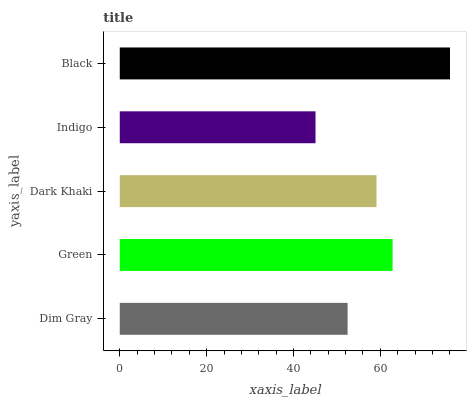Is Indigo the minimum?
Answer yes or no. Yes. Is Black the maximum?
Answer yes or no. Yes. Is Green the minimum?
Answer yes or no. No. Is Green the maximum?
Answer yes or no. No. Is Green greater than Dim Gray?
Answer yes or no. Yes. Is Dim Gray less than Green?
Answer yes or no. Yes. Is Dim Gray greater than Green?
Answer yes or no. No. Is Green less than Dim Gray?
Answer yes or no. No. Is Dark Khaki the high median?
Answer yes or no. Yes. Is Dark Khaki the low median?
Answer yes or no. Yes. Is Green the high median?
Answer yes or no. No. Is Green the low median?
Answer yes or no. No. 